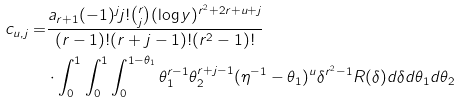Convert formula to latex. <formula><loc_0><loc_0><loc_500><loc_500>c _ { u , j } = & \frac { a _ { r + 1 } ( - 1 ) ^ { j } j ! \binom { r } { j } ( \log y ) ^ { r ^ { 2 } + 2 r + u + j } } { ( r - 1 ) ! ( r + j - 1 ) ! ( r ^ { 2 } - 1 ) ! } \\ & \cdot \int _ { 0 } ^ { 1 } \int _ { 0 } ^ { 1 } \int _ { 0 } ^ { 1 - \theta _ { 1 } } \theta _ { 1 } ^ { r - 1 } \theta _ { 2 } ^ { r + j - 1 } ( \eta ^ { - 1 } - \theta _ { 1 } ) ^ { u } \delta ^ { r ^ { 2 } - 1 } R ( \delta ) d \delta d \theta _ { 1 } d \theta _ { 2 }</formula> 